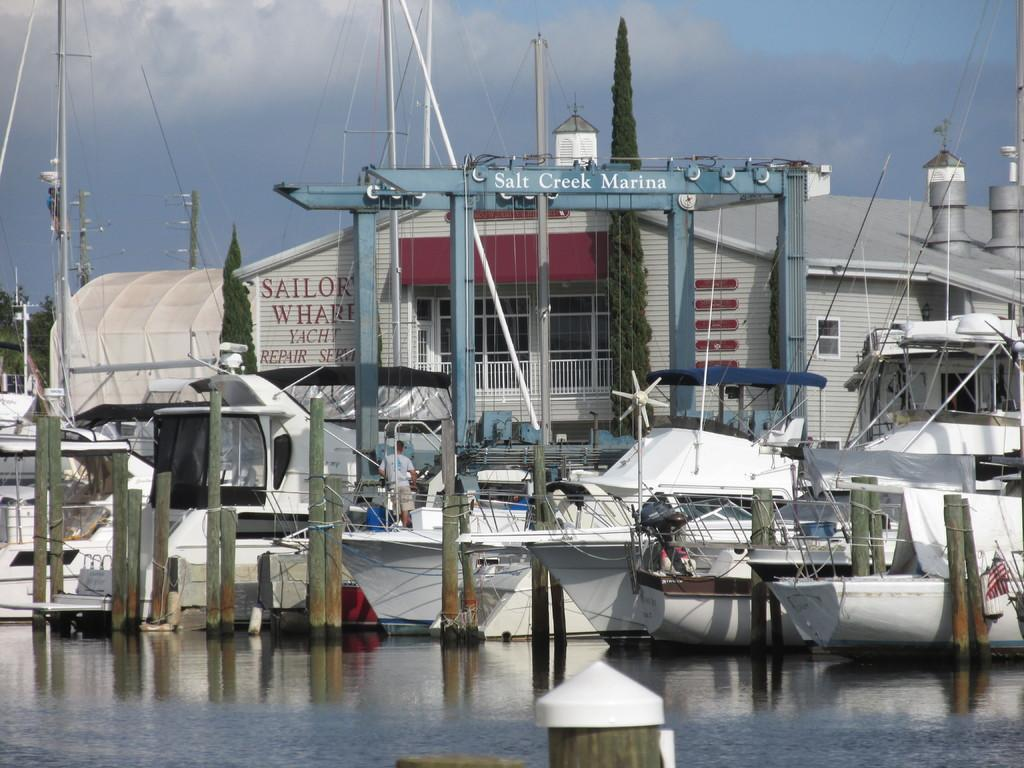Provide a one-sentence caption for the provided image. A row of boats are moored at the Salt Creek Marina. 